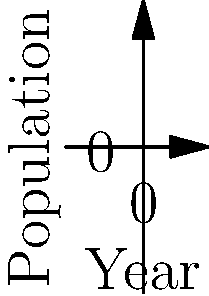As a wildlife tourism advocate, you're analyzing population trends of endangered species. Based on the graph, which species shows the most promising population growth between 2000 and 2020, and how might this trend impact responsible wildlife tourism practices? To answer this question, we need to analyze the population trends for each species shown in the graph:

1. Tiger (blue line):
   - Starting population in 2000: approximately 3,200
   - Ending population in 2020: approximately 4,500
   - Shows a steady increase over the 20-year period

2. Rhino (red line):
   - Starting population in 2000: approximately 2,400
   - Ending population in 2020: approximately 1,600
   - Shows a consistent decline over the 20-year period

3. Elephant (green line):
   - Starting population in 2000: approximately 5,000
   - Ending population in 2020: approximately 3,900
   - Shows a gradual decline over the 20-year period

Comparing these trends, the tiger population shows the most promising growth. It's the only species among the three that demonstrates a positive trend, increasing from about 3,200 to 4,500 over the 20-year period.

This trend could impact responsible wildlife tourism practices in several ways:

1. Increased opportunities for tiger sightings, potentially leading to more interest in tiger-focused tours.
2. Need for stricter regulations to manage increased tourism without disturbing the recovering population.
3. Potential for using the tiger's success story to educate tourists about conservation efforts.
4. Possibility of redirecting some tourism focus from declining species (rhinos and elephants) to the more abundant tigers, to reduce pressure on struggling populations.

As a responsible wildlife tourism advocate, it would be important to emphasize sustainable practices that allow tourists to observe tigers without negatively impacting their habitats or behavior, while also using this positive trend to highlight the importance of conservation efforts for all endangered species.
Answer: Tigers show the most promising growth. This may lead to increased tiger-focused tourism, requiring careful management to balance opportunities with conservation. 